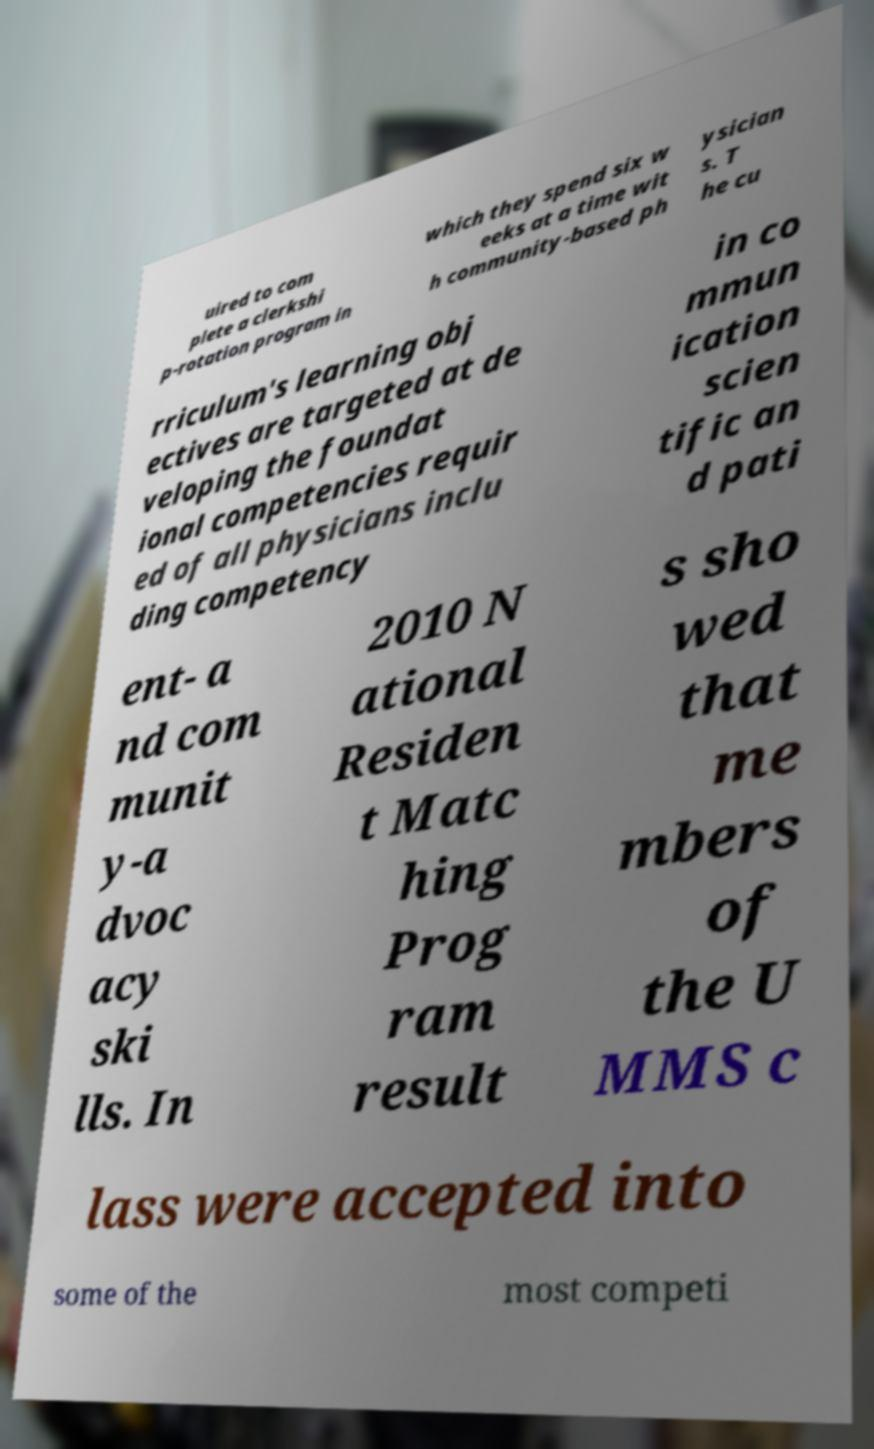Could you assist in decoding the text presented in this image and type it out clearly? uired to com plete a clerkshi p-rotation program in which they spend six w eeks at a time wit h community-based ph ysician s. T he cu rriculum's learning obj ectives are targeted at de veloping the foundat ional competencies requir ed of all physicians inclu ding competency in co mmun ication scien tific an d pati ent- a nd com munit y-a dvoc acy ski lls. In 2010 N ational Residen t Matc hing Prog ram result s sho wed that me mbers of the U MMS c lass were accepted into some of the most competi 